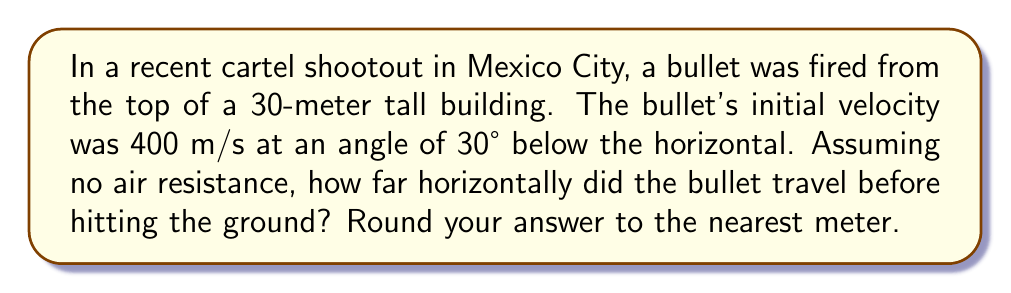Teach me how to tackle this problem. Let's approach this problem step-by-step using projectile motion equations and trigonometry:

1) First, we need to break down the initial velocity into its horizontal and vertical components:

   $v_x = 400 \cos(30°) = 400 \cdot \frac{\sqrt{3}}{2} \approx 346.41$ m/s
   $v_y = -400 \sin(30°) = -400 \cdot \frac{1}{2} = -200$ m/s (negative because it's going downward)

2) Now, we can use the equation for the time it takes for the bullet to hit the ground:

   $$y = y_0 + v_yt + \frac{1}{2}gt^2$$

   Where $y = 0$ (ground level), $y_0 = 30$ m (initial height), $v_y = -200$ m/s, and $g = 9.8$ m/s².

3) Substituting these values:

   $$0 = 30 + (-200)t + \frac{1}{2}(9.8)t^2$$

4) Simplifying:

   $$4.9t^2 - 200t + 30 = 0$$

5) This is a quadratic equation. We can solve it using the quadratic formula:

   $$t = \frac{-b \pm \sqrt{b^2 - 4ac}}{2a}$$

   Where $a = 4.9$, $b = -200$, and $c = 30$

6) Solving this:

   $$t = \frac{200 \pm \sqrt{40000 - 588}}{9.8} \approx 1.56$$ seconds (we take the positive solution)

7) Now that we know the time, we can calculate the horizontal distance:

   $$x = v_xt = 346.41 \cdot 1.56 \approx 540.40$$ meters

8) Rounding to the nearest meter:

   540 meters
Answer: 540 meters 